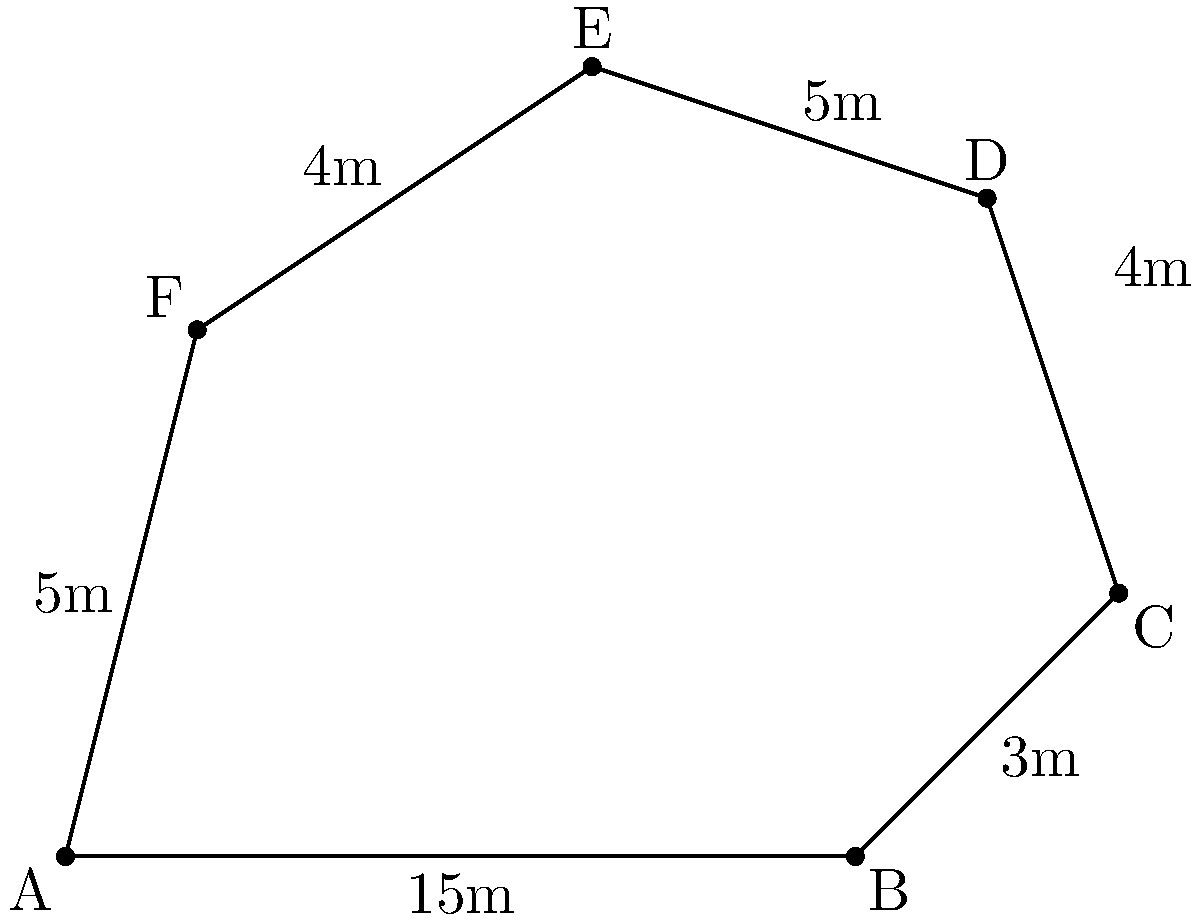During a beach clean-up event, you've marked an irregular-shaped cleanup zone with flags at points A, B, C, D, E, and F. The distances between consecutive flags are shown in the diagram. What is the total perimeter of this cleanup zone in meters? To find the perimeter of the irregular-shaped cleanup zone, we need to add up the distances between all consecutive flags. Let's go through this step-by-step:

1. Distance AB = 15m
2. Distance BC = 3m
3. Distance CD = 4m
4. Distance DE = 5m
5. Distance EF = 4m
6. Distance FA = 5m

Now, let's sum up all these distances:

$$\text{Perimeter} = AB + BC + CD + DE + EF + FA$$
$$\text{Perimeter} = 15 + 3 + 4 + 5 + 4 + 5$$
$$\text{Perimeter} = 36\text{ meters}$$

Therefore, the total perimeter of the cleanup zone is 36 meters.
Answer: 36 meters 